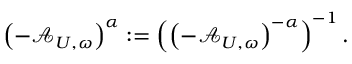<formula> <loc_0><loc_0><loc_500><loc_500>\left ( - \mathcal { A } _ { U , \omega } \right ) ^ { \alpha } \colon = \left ( \left ( - \mathcal { A } _ { U , \omega } \right ) ^ { - \alpha } \right ) ^ { - 1 } .</formula> 